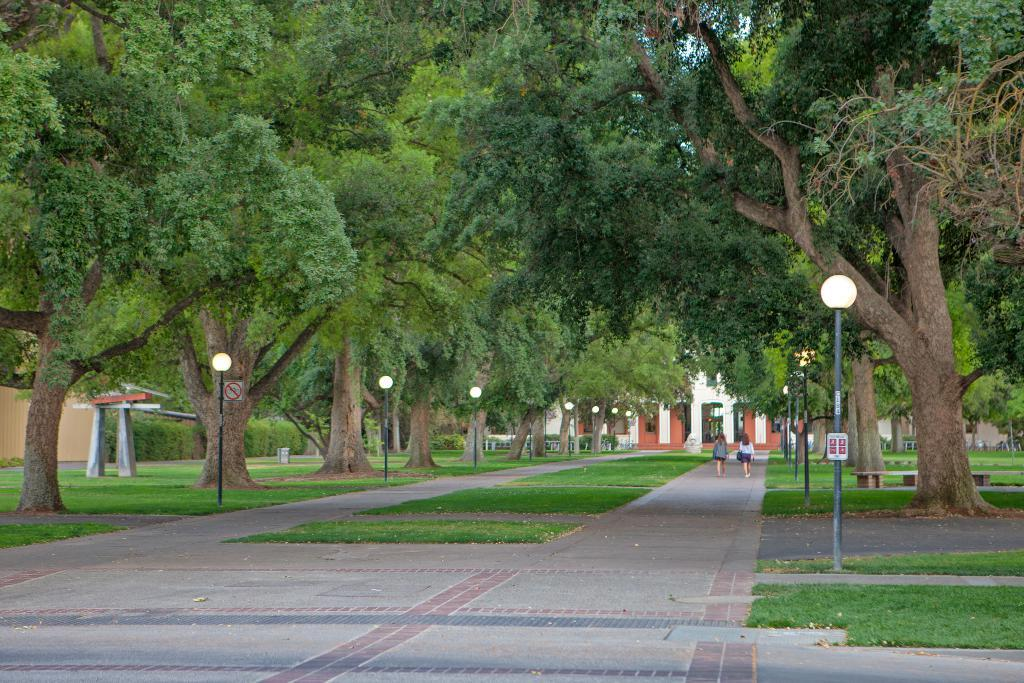What type of vertical structures are present in the image? There are light poles in the image. What type of informational structures are present in the image? There are sign-boards in the image. What type of natural elements are present in the image? There are trees and grass in the image. What type of man-made structure is visible in the distance? There is a building visible in the distance. What type of living organisms are visible in the distance? There are people visible in the distance. What type of vegetable is being harvested in the image? There is no vegetable being harvested in the image; it features light poles, sign-boards, trees, grass, a building, and people. How does the wave crash against the shore in the image? There is no wave crashing against the shore in the image. 